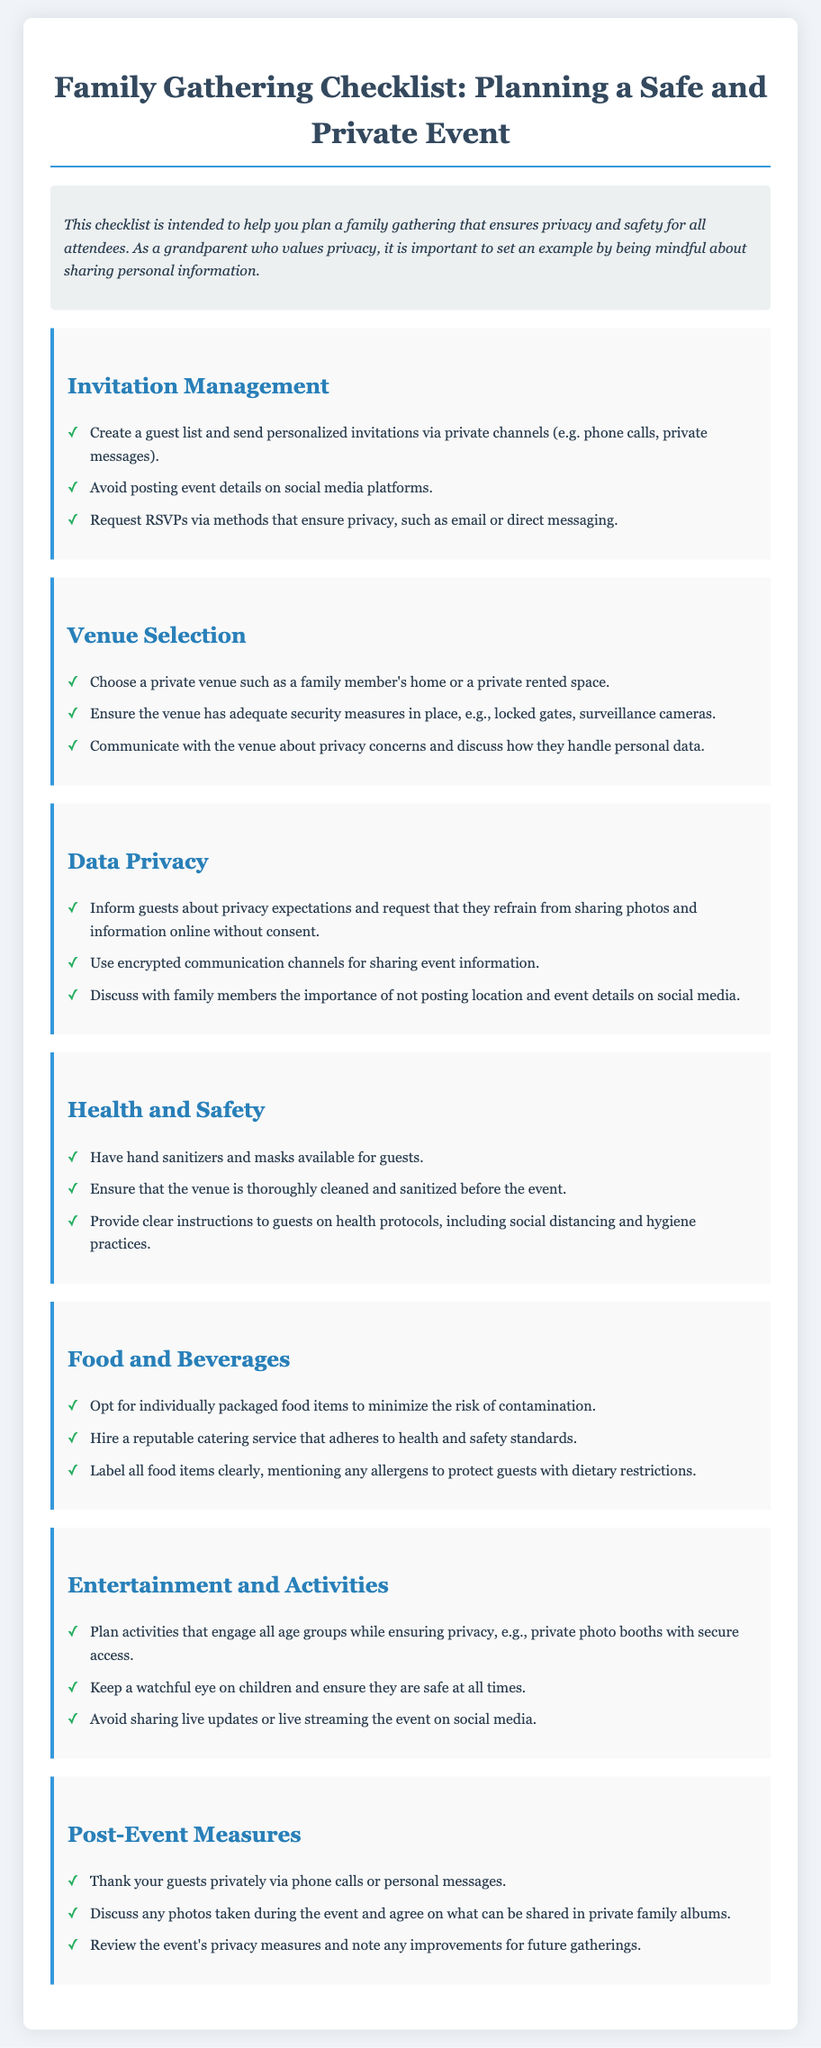what is the title of the document? The title is presented at the top of the rendered document, which describes its content.
Answer: Family Gathering Checklist: Planning a Safe and Private Event how should invitations be sent? This information can be found under the "Invitation Management" section, which outlines best practices for sending invitations.
Answer: Private channels what should guests be informed about regarding photos? This is found in the "Data Privacy" section, which discusses sharing of photos and personal information.
Answer: Privacy expectations what type of food packaging is recommended? The recommendation is listed in the "Food and Beverages" section for minimizing contamination.
Answer: Individually packaged what health protocols should be communicated to guests? The "Health and Safety" section provides necessary health instructions for attendees.
Answer: Clear instructions how should guests be thanked after the event? The suggested method for expressing gratitude to guests is detailed in the "Post-Event Measures" section.
Answer: Privately via phone calls what venue type is recommended for privacy? This recommendation is specified in the "Venue Selection" section focusing on privacy considerations.
Answer: Family member's home how can event activities ensure privacy? This is mentioned in the "Entertainment and Activities" section, highlighting privacy in activities.
Answer: Secure access what is the preferred method for RSVPs? This detail is provided in the "Invitation Management" section, which explains RSVP procedures.
Answer: Email or direct messaging 